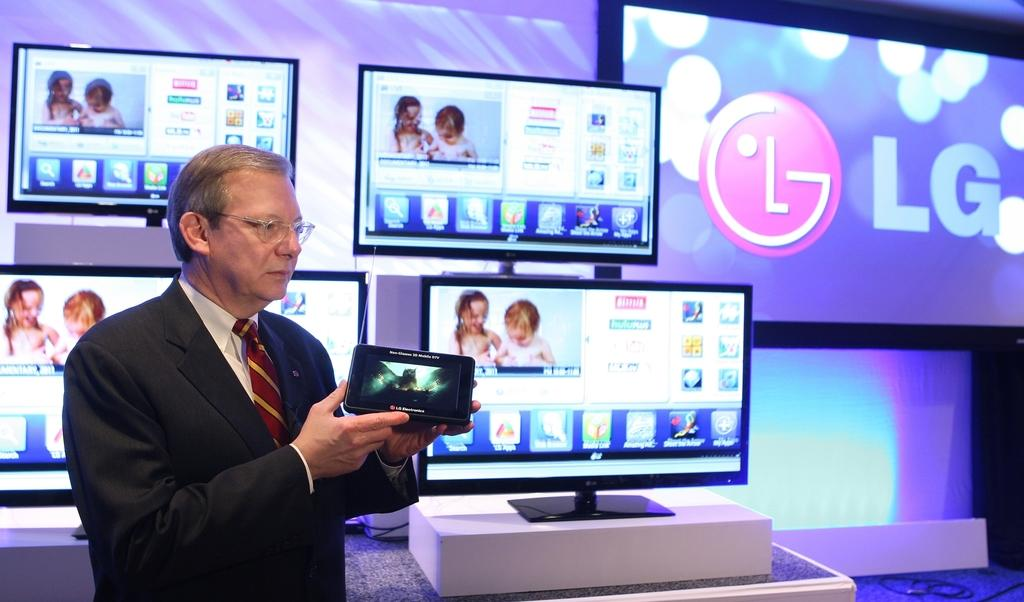<image>
Write a terse but informative summary of the picture. Man displaying and showing a screen of an LG product. 